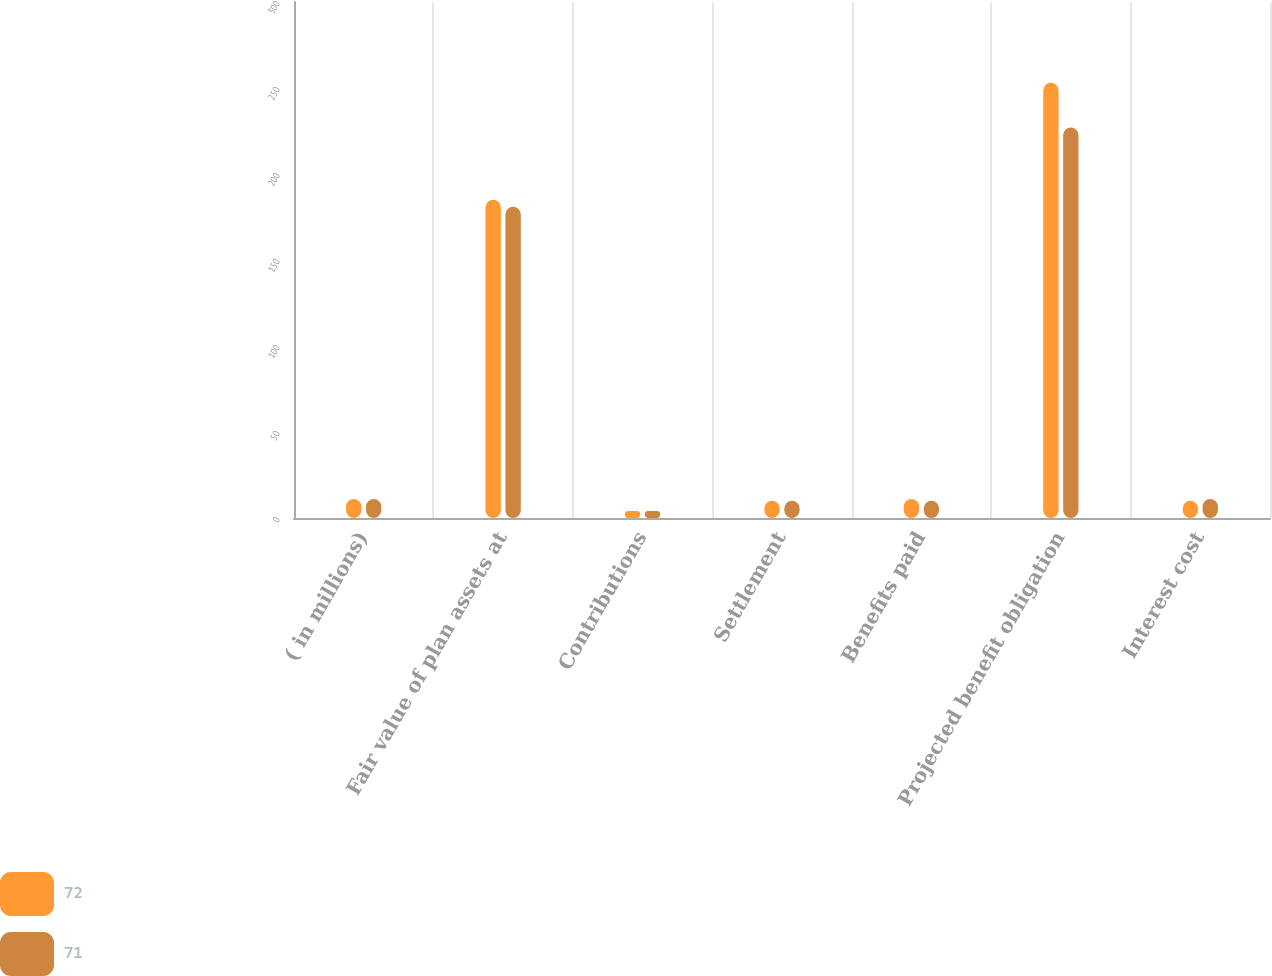Convert chart to OTSL. <chart><loc_0><loc_0><loc_500><loc_500><stacked_bar_chart><ecel><fcel>( in millions)<fcel>Fair value of plan assets at<fcel>Contributions<fcel>Settlement<fcel>Benefits paid<fcel>Projected benefit obligation<fcel>Interest cost<nl><fcel>72<fcel>11<fcel>185<fcel>4<fcel>10<fcel>11<fcel>253<fcel>10<nl><fcel>71<fcel>11<fcel>181<fcel>4<fcel>10<fcel>10<fcel>227<fcel>11<nl></chart> 